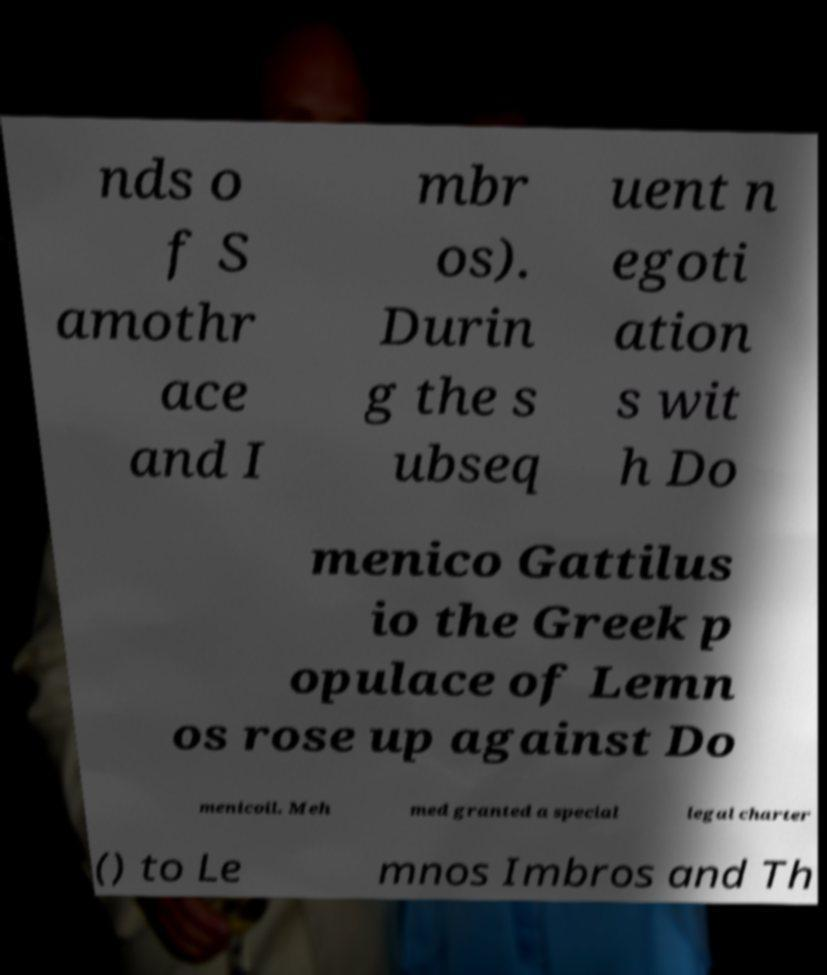Could you assist in decoding the text presented in this image and type it out clearly? nds o f S amothr ace and I mbr os). Durin g the s ubseq uent n egoti ation s wit h Do menico Gattilus io the Greek p opulace of Lemn os rose up against Do menicoil. Meh med granted a special legal charter () to Le mnos Imbros and Th 